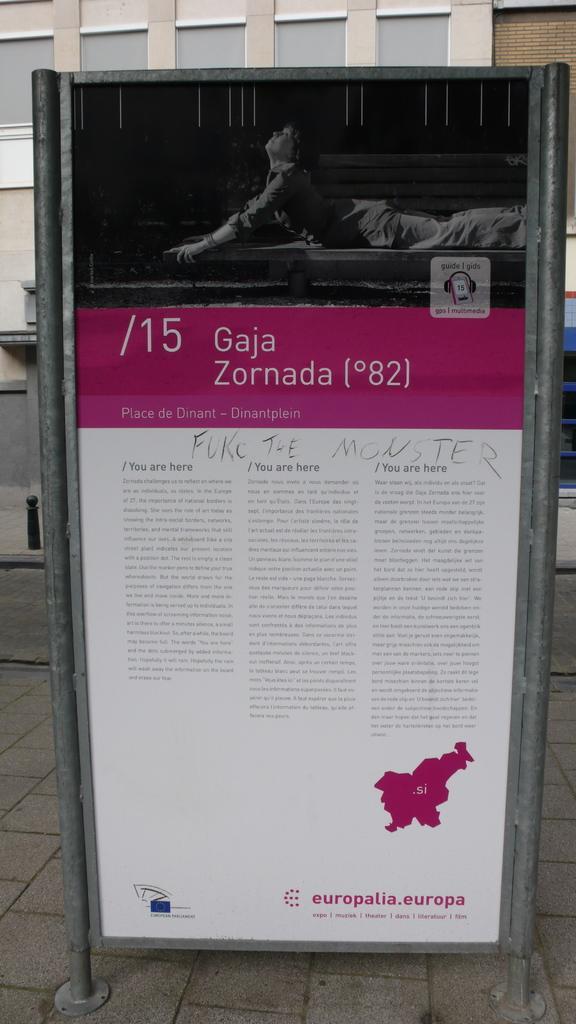Could you give a brief overview of what you see in this image? In this image we can see a board in which a person is lying and some text was written on the board, behind it a building is there. 